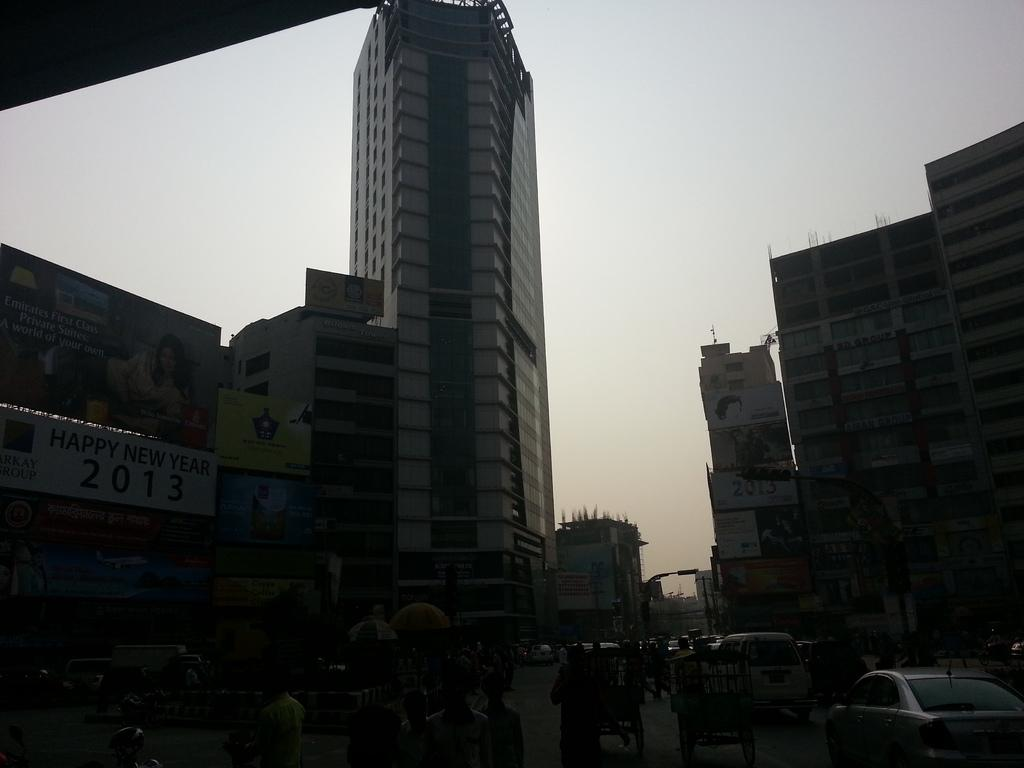What is the main feature of the image? There is a road in the image. What can be seen on the road? There are many people, carts, and vehicles on the road. What is present on the sides of the road? There are buildings and banners on the sides of the road. What can be seen in the background of the image? The sky is visible in the background. What type of sweater is the person wearing in the image? There is no person wearing a sweater in the image; the focus is on the road and its surroundings. How many feet are visible in the image? There is no specific focus on feet in the image; the main subjects are the road, people, carts, vehicles, buildings, and banners. 